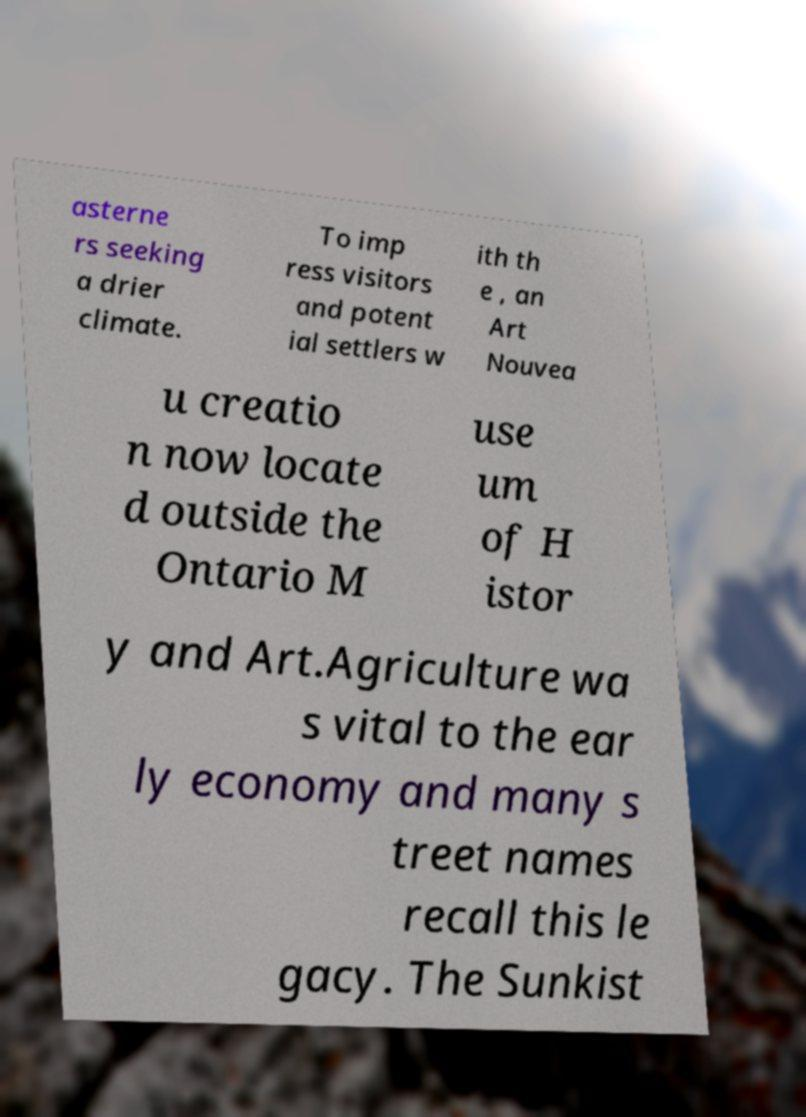What messages or text are displayed in this image? I need them in a readable, typed format. asterne rs seeking a drier climate. To imp ress visitors and potent ial settlers w ith th e , an Art Nouvea u creatio n now locate d outside the Ontario M use um of H istor y and Art.Agriculture wa s vital to the ear ly economy and many s treet names recall this le gacy. The Sunkist 